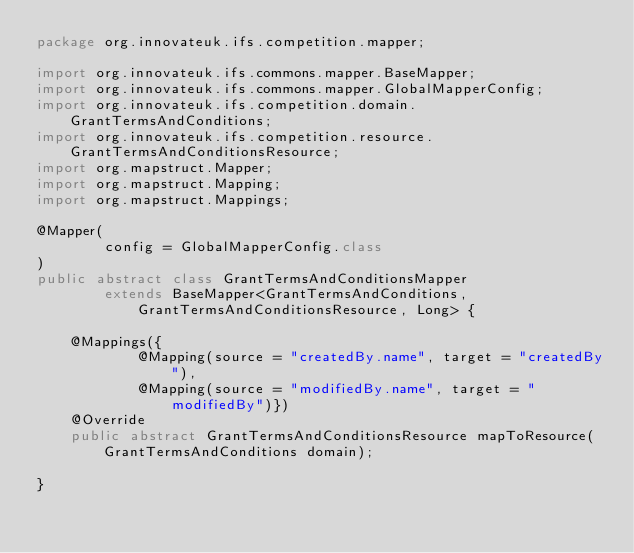<code> <loc_0><loc_0><loc_500><loc_500><_Java_>package org.innovateuk.ifs.competition.mapper;

import org.innovateuk.ifs.commons.mapper.BaseMapper;
import org.innovateuk.ifs.commons.mapper.GlobalMapperConfig;
import org.innovateuk.ifs.competition.domain.GrantTermsAndConditions;
import org.innovateuk.ifs.competition.resource.GrantTermsAndConditionsResource;
import org.mapstruct.Mapper;
import org.mapstruct.Mapping;
import org.mapstruct.Mappings;

@Mapper(
        config = GlobalMapperConfig.class
)
public abstract class GrantTermsAndConditionsMapper
        extends BaseMapper<GrantTermsAndConditions, GrantTermsAndConditionsResource, Long> {

    @Mappings({
            @Mapping(source = "createdBy.name", target = "createdBy"),
            @Mapping(source = "modifiedBy.name", target = "modifiedBy")})
    @Override
    public abstract GrantTermsAndConditionsResource mapToResource(GrantTermsAndConditions domain);

}
</code> 